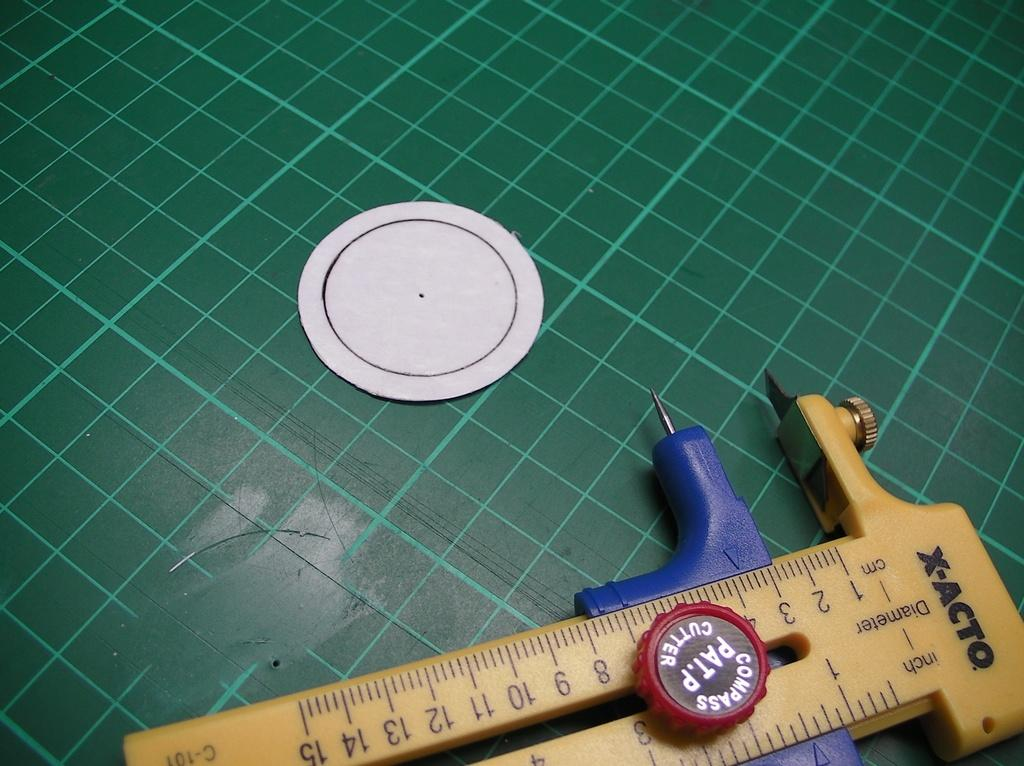Provide a one-sentence caption for the provided image. An X-Acto measuring device is laying on a green surface. 